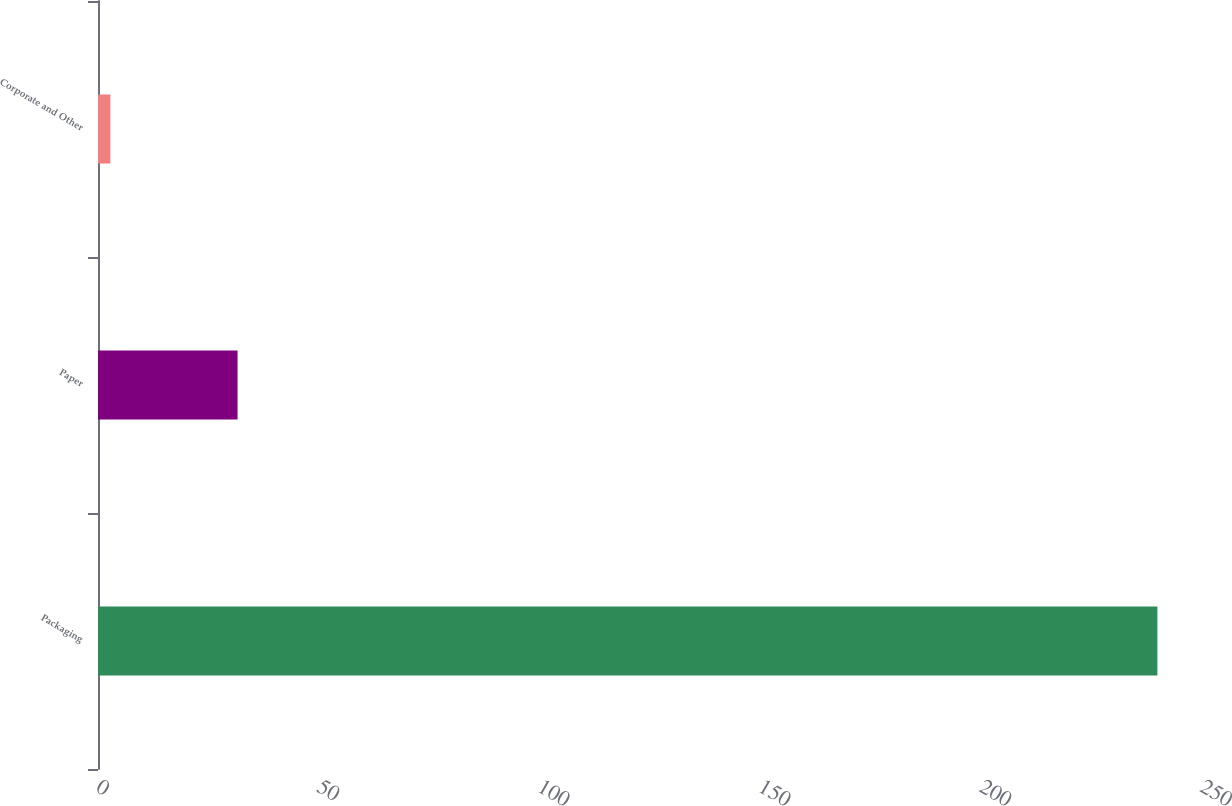<chart> <loc_0><loc_0><loc_500><loc_500><bar_chart><fcel>Packaging<fcel>Paper<fcel>Corporate and Other<nl><fcel>239.9<fcel>31.6<fcel>2.8<nl></chart> 